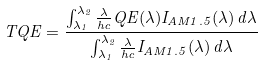<formula> <loc_0><loc_0><loc_500><loc_500>T Q E = \frac { \int _ { \lambda _ { 1 } } ^ { \lambda _ { 2 } } \frac { \lambda } { h c } Q E ( \lambda ) I _ { A M 1 . 5 } ( \lambda ) \, d \lambda } { \int _ { \lambda _ { 1 } } ^ { \lambda _ { 2 } } \frac { \lambda } { h c } I _ { A M 1 . 5 } ( \lambda ) \, d \lambda }</formula> 